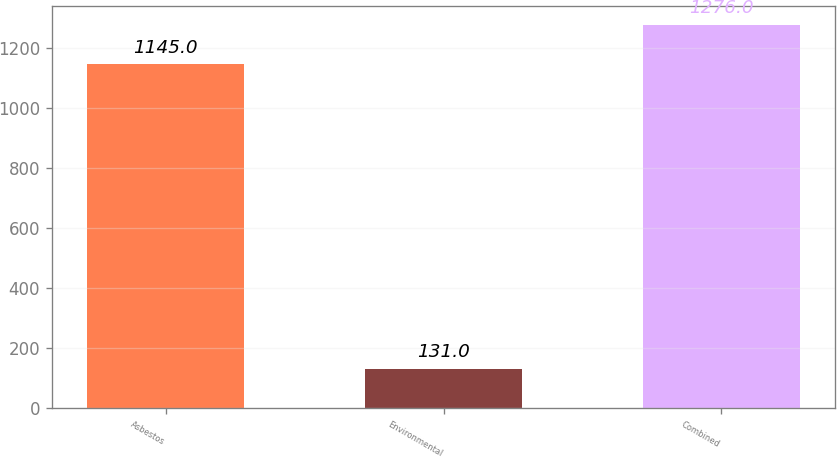Convert chart to OTSL. <chart><loc_0><loc_0><loc_500><loc_500><bar_chart><fcel>Asbestos<fcel>Environmental<fcel>Combined<nl><fcel>1145<fcel>131<fcel>1276<nl></chart> 